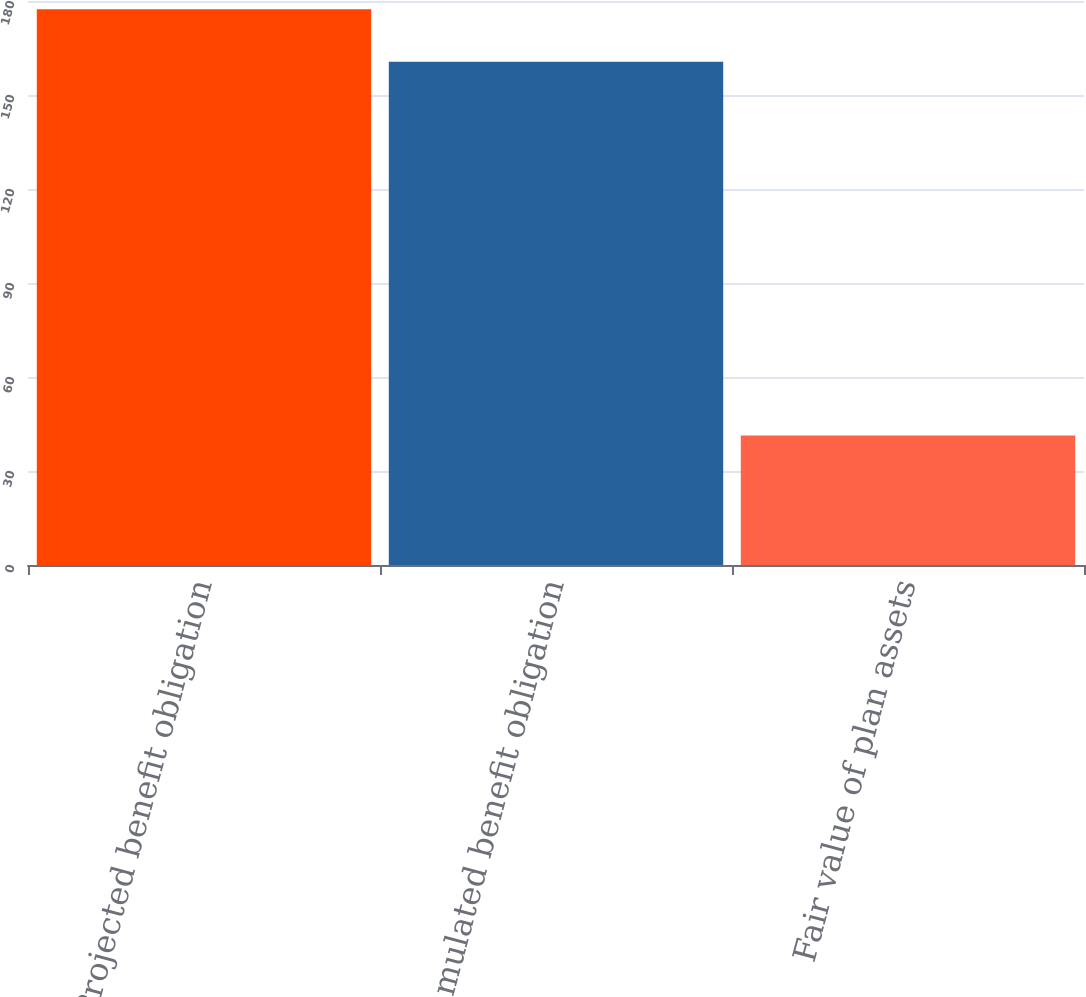Convert chart to OTSL. <chart><loc_0><loc_0><loc_500><loc_500><bar_chart><fcel>Projected benefit obligation<fcel>Accumulated benefit obligation<fcel>Fair value of plan assets<nl><fcel>177.4<fcel>160.6<fcel>41.3<nl></chart> 